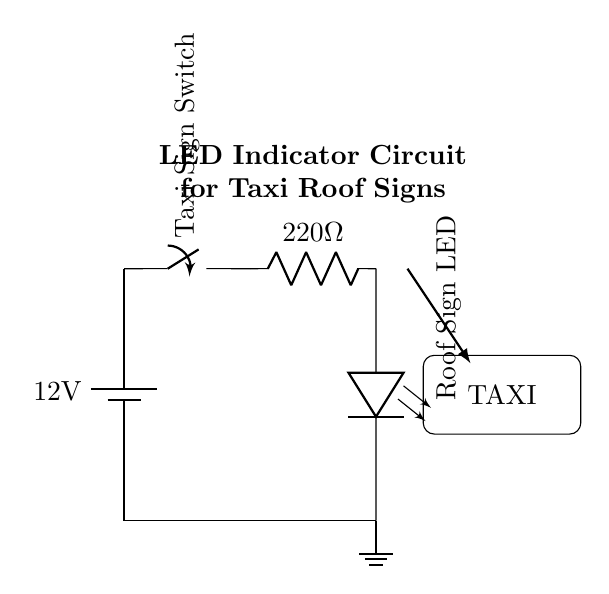What is the voltage of this circuit? The voltage is twelve volts, which is specified by the battery component labeled with the voltage value.
Answer: twelve volts What type of component is the LED? The LED is a light-emitting diode, which is indicated by the symbol for the LED in the circuit diagram.
Answer: light-emitting diode What is the value of the resistor used in the circuit? The resistor value is two hundred twenty ohms, which is explicitly noted next to the resistor symbol in the circuit.
Answer: two hundred twenty ohms Which component serves as the switch in this circuit? The switch is the component marked as "Taxi Sign Switch," indicating its function to control the circuit's operation.
Answer: Taxi Sign Switch What is the purpose of the switch in this circuit? The switch controls the operation of the LED, allowing it to be turned on or off, which is essential for signaling with the taxi roof sign.
Answer: control LED If the switch is closed, what happens to the LED? If the switch is closed, the circuit is completed, allowing current to flow from the battery through the resistor and to the LED, which will then light up.
Answer: LED lights up Why is the resistor included in the circuit? The resistor limits the current flowing through the LED to prevent it from exceeding the maximum rating, ensuring the LED operates safely.
Answer: limit current 